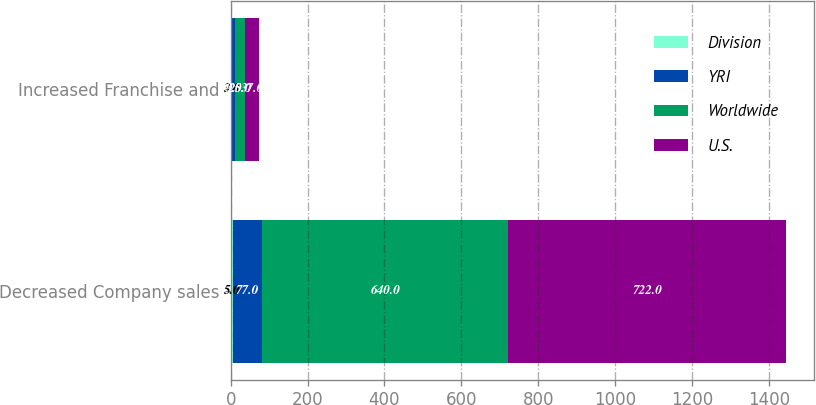<chart> <loc_0><loc_0><loc_500><loc_500><stacked_bar_chart><ecel><fcel>Decreased Company sales<fcel>Increased Franchise and<nl><fcel>Division<fcel>5<fcel>3<nl><fcel>YRI<fcel>77<fcel>9<nl><fcel>Worldwide<fcel>640<fcel>25<nl><fcel>U.S.<fcel>722<fcel>37<nl></chart> 